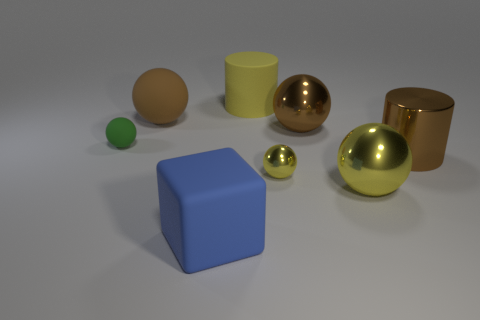Subtract all yellow cylinders. How many yellow balls are left? 2 Subtract all tiny yellow spheres. How many spheres are left? 4 Subtract 1 spheres. How many spheres are left? 4 Subtract all green balls. How many balls are left? 4 Add 1 yellow metallic things. How many objects exist? 9 Subtract all red spheres. Subtract all green cylinders. How many spheres are left? 5 Subtract all cubes. How many objects are left? 7 Add 8 big rubber cylinders. How many big rubber cylinders are left? 9 Add 1 tiny green matte objects. How many tiny green matte objects exist? 2 Subtract 1 yellow cylinders. How many objects are left? 7 